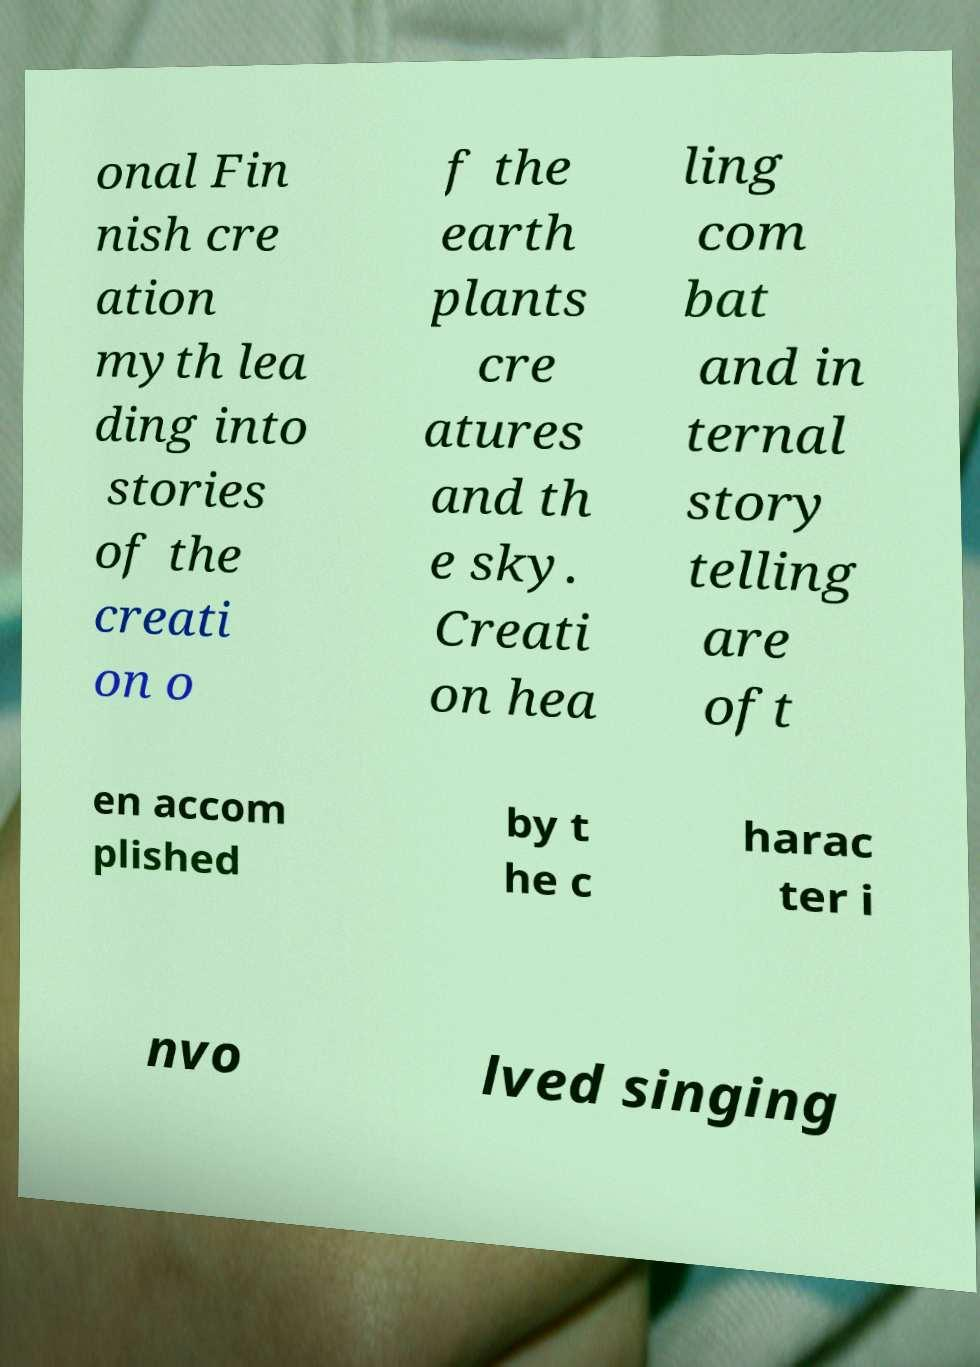Please read and relay the text visible in this image. What does it say? onal Fin nish cre ation myth lea ding into stories of the creati on o f the earth plants cre atures and th e sky. Creati on hea ling com bat and in ternal story telling are oft en accom plished by t he c harac ter i nvo lved singing 